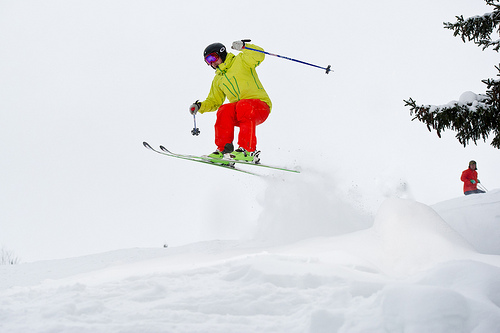Please provide a short description for this region: [0.33, 0.35, 0.58, 0.51]. The skier's legs are bent at the knees in a poised position for landing, decked out in bright orange ski pants. 